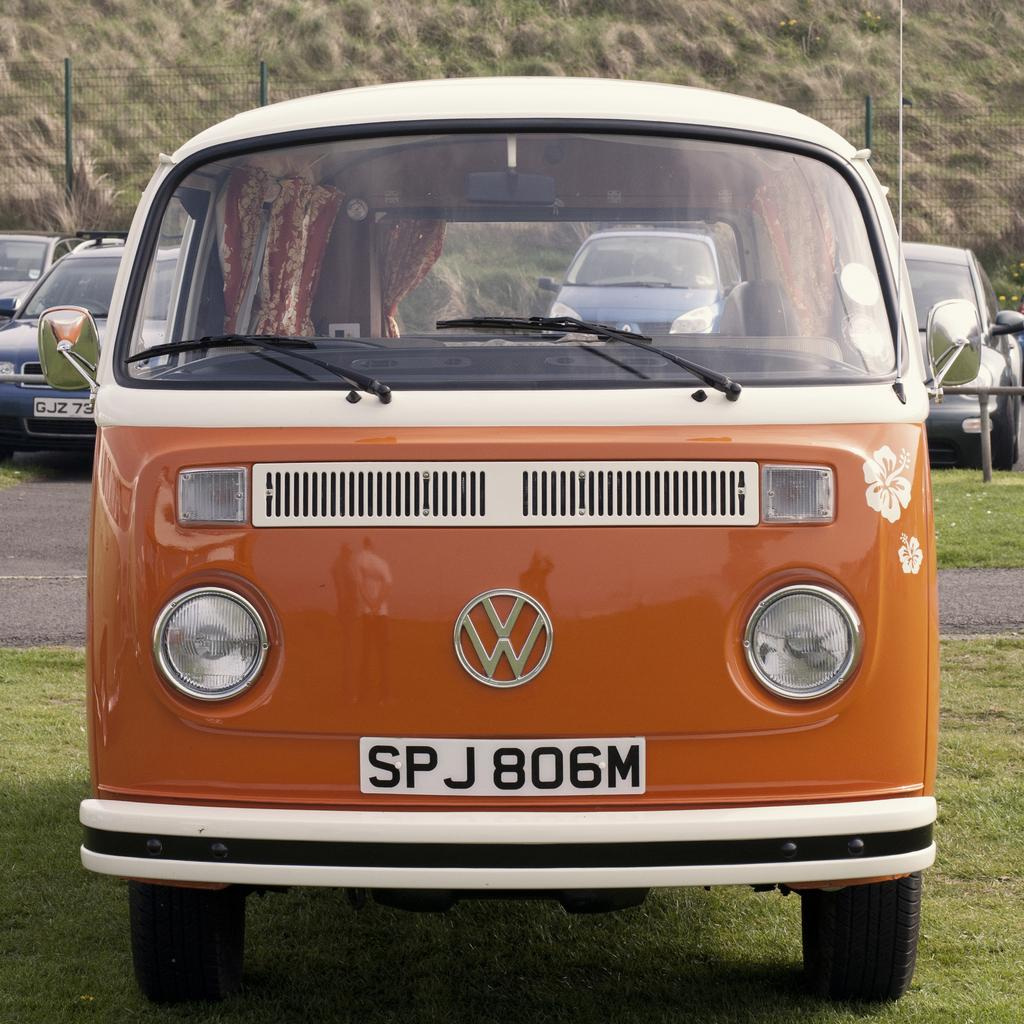<image>
Create a compact narrative representing the image presented. An orange and white retro VW van with the licence plat SP 806M 